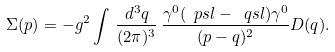Convert formula to latex. <formula><loc_0><loc_0><loc_500><loc_500>\Sigma ( p ) = - g ^ { 2 } \int \, \frac { d ^ { 3 } q } { ( 2 \pi ) ^ { 3 } } \, \frac { \gamma ^ { 0 } ( \ p s l - \ q s l ) \gamma ^ { 0 } } { ( p - q ) ^ { 2 } } D ( q ) .</formula> 